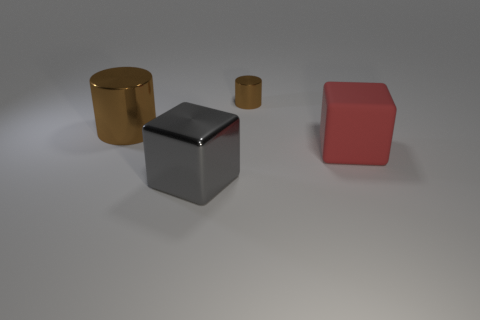Subtract 2 blocks. How many blocks are left? 0 Subtract all red cylinders. Subtract all cyan balls. How many cylinders are left? 2 Subtract all green spheres. How many blue cylinders are left? 0 Subtract all red matte spheres. Subtract all matte objects. How many objects are left? 3 Add 1 red cubes. How many red cubes are left? 2 Add 1 brown metal cylinders. How many brown metal cylinders exist? 3 Add 4 small matte objects. How many objects exist? 8 Subtract all gray blocks. How many blocks are left? 1 Subtract 0 yellow spheres. How many objects are left? 4 